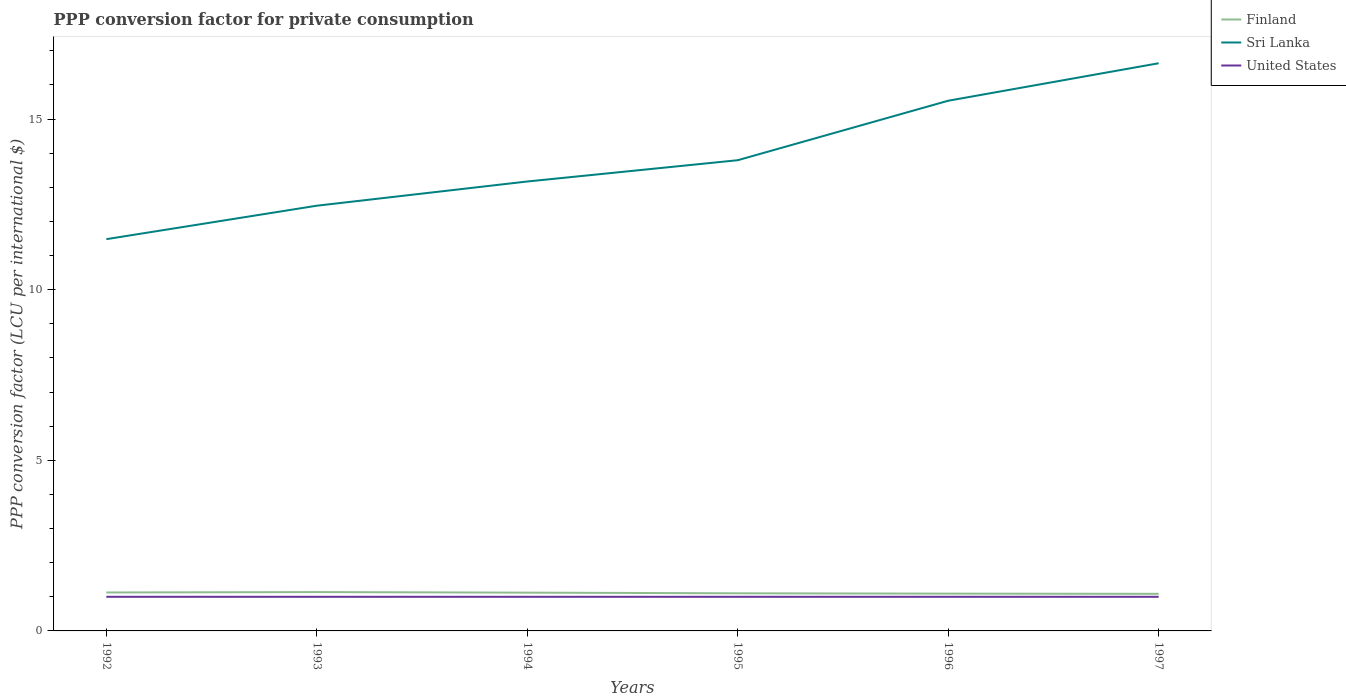How many different coloured lines are there?
Give a very brief answer. 3. Across all years, what is the maximum PPP conversion factor for private consumption in Finland?
Your response must be concise. 1.09. What is the total PPP conversion factor for private consumption in Finland in the graph?
Offer a terse response. 0.04. What is the difference between the highest and the second highest PPP conversion factor for private consumption in Sri Lanka?
Your answer should be very brief. 5.16. What is the difference between the highest and the lowest PPP conversion factor for private consumption in United States?
Keep it short and to the point. 0. What is the difference between two consecutive major ticks on the Y-axis?
Offer a very short reply. 5. Does the graph contain any zero values?
Make the answer very short. No. How are the legend labels stacked?
Ensure brevity in your answer.  Vertical. What is the title of the graph?
Ensure brevity in your answer.  PPP conversion factor for private consumption. What is the label or title of the Y-axis?
Ensure brevity in your answer.  PPP conversion factor (LCU per international $). What is the PPP conversion factor (LCU per international $) of Finland in 1992?
Your answer should be compact. 1.13. What is the PPP conversion factor (LCU per international $) in Sri Lanka in 1992?
Offer a terse response. 11.48. What is the PPP conversion factor (LCU per international $) of United States in 1992?
Provide a succinct answer. 1. What is the PPP conversion factor (LCU per international $) of Finland in 1993?
Provide a succinct answer. 1.14. What is the PPP conversion factor (LCU per international $) of Sri Lanka in 1993?
Ensure brevity in your answer.  12.46. What is the PPP conversion factor (LCU per international $) of Finland in 1994?
Your response must be concise. 1.12. What is the PPP conversion factor (LCU per international $) in Sri Lanka in 1994?
Your answer should be compact. 13.17. What is the PPP conversion factor (LCU per international $) in Finland in 1995?
Offer a very short reply. 1.1. What is the PPP conversion factor (LCU per international $) of Sri Lanka in 1995?
Keep it short and to the point. 13.79. What is the PPP conversion factor (LCU per international $) in United States in 1995?
Make the answer very short. 1. What is the PPP conversion factor (LCU per international $) in Finland in 1996?
Make the answer very short. 1.09. What is the PPP conversion factor (LCU per international $) of Sri Lanka in 1996?
Provide a short and direct response. 15.54. What is the PPP conversion factor (LCU per international $) in Finland in 1997?
Your answer should be compact. 1.09. What is the PPP conversion factor (LCU per international $) in Sri Lanka in 1997?
Offer a terse response. 16.64. Across all years, what is the maximum PPP conversion factor (LCU per international $) in Finland?
Ensure brevity in your answer.  1.14. Across all years, what is the maximum PPP conversion factor (LCU per international $) of Sri Lanka?
Your answer should be very brief. 16.64. Across all years, what is the maximum PPP conversion factor (LCU per international $) in United States?
Make the answer very short. 1. Across all years, what is the minimum PPP conversion factor (LCU per international $) in Finland?
Offer a terse response. 1.09. Across all years, what is the minimum PPP conversion factor (LCU per international $) of Sri Lanka?
Ensure brevity in your answer.  11.48. What is the total PPP conversion factor (LCU per international $) of Finland in the graph?
Give a very brief answer. 6.67. What is the total PPP conversion factor (LCU per international $) of Sri Lanka in the graph?
Offer a very short reply. 83.08. What is the difference between the PPP conversion factor (LCU per international $) of Finland in 1992 and that in 1993?
Make the answer very short. -0.01. What is the difference between the PPP conversion factor (LCU per international $) in Sri Lanka in 1992 and that in 1993?
Ensure brevity in your answer.  -0.98. What is the difference between the PPP conversion factor (LCU per international $) in Finland in 1992 and that in 1994?
Ensure brevity in your answer.  0. What is the difference between the PPP conversion factor (LCU per international $) in Sri Lanka in 1992 and that in 1994?
Your answer should be compact. -1.69. What is the difference between the PPP conversion factor (LCU per international $) of Finland in 1992 and that in 1995?
Offer a very short reply. 0.02. What is the difference between the PPP conversion factor (LCU per international $) of Sri Lanka in 1992 and that in 1995?
Make the answer very short. -2.31. What is the difference between the PPP conversion factor (LCU per international $) in United States in 1992 and that in 1995?
Your response must be concise. 0. What is the difference between the PPP conversion factor (LCU per international $) of Finland in 1992 and that in 1996?
Provide a short and direct response. 0.03. What is the difference between the PPP conversion factor (LCU per international $) in Sri Lanka in 1992 and that in 1996?
Provide a succinct answer. -4.06. What is the difference between the PPP conversion factor (LCU per international $) of United States in 1992 and that in 1996?
Keep it short and to the point. 0. What is the difference between the PPP conversion factor (LCU per international $) of Finland in 1992 and that in 1997?
Give a very brief answer. 0.04. What is the difference between the PPP conversion factor (LCU per international $) in Sri Lanka in 1992 and that in 1997?
Offer a very short reply. -5.16. What is the difference between the PPP conversion factor (LCU per international $) of Finland in 1993 and that in 1994?
Provide a succinct answer. 0.02. What is the difference between the PPP conversion factor (LCU per international $) in Sri Lanka in 1993 and that in 1994?
Your answer should be very brief. -0.71. What is the difference between the PPP conversion factor (LCU per international $) of United States in 1993 and that in 1994?
Provide a succinct answer. 0. What is the difference between the PPP conversion factor (LCU per international $) of Finland in 1993 and that in 1995?
Offer a terse response. 0.04. What is the difference between the PPP conversion factor (LCU per international $) in Sri Lanka in 1993 and that in 1995?
Make the answer very short. -1.33. What is the difference between the PPP conversion factor (LCU per international $) of Finland in 1993 and that in 1996?
Your response must be concise. 0.05. What is the difference between the PPP conversion factor (LCU per international $) of Sri Lanka in 1993 and that in 1996?
Ensure brevity in your answer.  -3.08. What is the difference between the PPP conversion factor (LCU per international $) in United States in 1993 and that in 1996?
Make the answer very short. 0. What is the difference between the PPP conversion factor (LCU per international $) of Finland in 1993 and that in 1997?
Ensure brevity in your answer.  0.05. What is the difference between the PPP conversion factor (LCU per international $) in Sri Lanka in 1993 and that in 1997?
Offer a very short reply. -4.17. What is the difference between the PPP conversion factor (LCU per international $) of United States in 1993 and that in 1997?
Your response must be concise. 0. What is the difference between the PPP conversion factor (LCU per international $) of Finland in 1994 and that in 1995?
Your response must be concise. 0.02. What is the difference between the PPP conversion factor (LCU per international $) in Sri Lanka in 1994 and that in 1995?
Offer a terse response. -0.62. What is the difference between the PPP conversion factor (LCU per international $) of United States in 1994 and that in 1995?
Ensure brevity in your answer.  0. What is the difference between the PPP conversion factor (LCU per international $) in Finland in 1994 and that in 1996?
Your response must be concise. 0.03. What is the difference between the PPP conversion factor (LCU per international $) in Sri Lanka in 1994 and that in 1996?
Make the answer very short. -2.37. What is the difference between the PPP conversion factor (LCU per international $) of Finland in 1994 and that in 1997?
Make the answer very short. 0.03. What is the difference between the PPP conversion factor (LCU per international $) of Sri Lanka in 1994 and that in 1997?
Give a very brief answer. -3.47. What is the difference between the PPP conversion factor (LCU per international $) of Finland in 1995 and that in 1996?
Your response must be concise. 0.01. What is the difference between the PPP conversion factor (LCU per international $) in Sri Lanka in 1995 and that in 1996?
Your answer should be very brief. -1.74. What is the difference between the PPP conversion factor (LCU per international $) in Finland in 1995 and that in 1997?
Ensure brevity in your answer.  0.02. What is the difference between the PPP conversion factor (LCU per international $) in Sri Lanka in 1995 and that in 1997?
Ensure brevity in your answer.  -2.84. What is the difference between the PPP conversion factor (LCU per international $) in Finland in 1996 and that in 1997?
Give a very brief answer. 0.01. What is the difference between the PPP conversion factor (LCU per international $) of Sri Lanka in 1996 and that in 1997?
Keep it short and to the point. -1.1. What is the difference between the PPP conversion factor (LCU per international $) in United States in 1996 and that in 1997?
Ensure brevity in your answer.  0. What is the difference between the PPP conversion factor (LCU per international $) of Finland in 1992 and the PPP conversion factor (LCU per international $) of Sri Lanka in 1993?
Provide a succinct answer. -11.34. What is the difference between the PPP conversion factor (LCU per international $) of Finland in 1992 and the PPP conversion factor (LCU per international $) of United States in 1993?
Provide a short and direct response. 0.13. What is the difference between the PPP conversion factor (LCU per international $) in Sri Lanka in 1992 and the PPP conversion factor (LCU per international $) in United States in 1993?
Your response must be concise. 10.48. What is the difference between the PPP conversion factor (LCU per international $) of Finland in 1992 and the PPP conversion factor (LCU per international $) of Sri Lanka in 1994?
Offer a very short reply. -12.04. What is the difference between the PPP conversion factor (LCU per international $) in Finland in 1992 and the PPP conversion factor (LCU per international $) in United States in 1994?
Make the answer very short. 0.13. What is the difference between the PPP conversion factor (LCU per international $) of Sri Lanka in 1992 and the PPP conversion factor (LCU per international $) of United States in 1994?
Your answer should be very brief. 10.48. What is the difference between the PPP conversion factor (LCU per international $) of Finland in 1992 and the PPP conversion factor (LCU per international $) of Sri Lanka in 1995?
Your response must be concise. -12.67. What is the difference between the PPP conversion factor (LCU per international $) of Finland in 1992 and the PPP conversion factor (LCU per international $) of United States in 1995?
Your answer should be compact. 0.13. What is the difference between the PPP conversion factor (LCU per international $) in Sri Lanka in 1992 and the PPP conversion factor (LCU per international $) in United States in 1995?
Offer a terse response. 10.48. What is the difference between the PPP conversion factor (LCU per international $) of Finland in 1992 and the PPP conversion factor (LCU per international $) of Sri Lanka in 1996?
Your answer should be very brief. -14.41. What is the difference between the PPP conversion factor (LCU per international $) of Finland in 1992 and the PPP conversion factor (LCU per international $) of United States in 1996?
Ensure brevity in your answer.  0.13. What is the difference between the PPP conversion factor (LCU per international $) in Sri Lanka in 1992 and the PPP conversion factor (LCU per international $) in United States in 1996?
Your answer should be compact. 10.48. What is the difference between the PPP conversion factor (LCU per international $) in Finland in 1992 and the PPP conversion factor (LCU per international $) in Sri Lanka in 1997?
Provide a short and direct response. -15.51. What is the difference between the PPP conversion factor (LCU per international $) of Finland in 1992 and the PPP conversion factor (LCU per international $) of United States in 1997?
Provide a succinct answer. 0.13. What is the difference between the PPP conversion factor (LCU per international $) in Sri Lanka in 1992 and the PPP conversion factor (LCU per international $) in United States in 1997?
Your answer should be compact. 10.48. What is the difference between the PPP conversion factor (LCU per international $) in Finland in 1993 and the PPP conversion factor (LCU per international $) in Sri Lanka in 1994?
Ensure brevity in your answer.  -12.03. What is the difference between the PPP conversion factor (LCU per international $) of Finland in 1993 and the PPP conversion factor (LCU per international $) of United States in 1994?
Give a very brief answer. 0.14. What is the difference between the PPP conversion factor (LCU per international $) in Sri Lanka in 1993 and the PPP conversion factor (LCU per international $) in United States in 1994?
Make the answer very short. 11.46. What is the difference between the PPP conversion factor (LCU per international $) of Finland in 1993 and the PPP conversion factor (LCU per international $) of Sri Lanka in 1995?
Keep it short and to the point. -12.66. What is the difference between the PPP conversion factor (LCU per international $) in Finland in 1993 and the PPP conversion factor (LCU per international $) in United States in 1995?
Offer a very short reply. 0.14. What is the difference between the PPP conversion factor (LCU per international $) of Sri Lanka in 1993 and the PPP conversion factor (LCU per international $) of United States in 1995?
Provide a succinct answer. 11.46. What is the difference between the PPP conversion factor (LCU per international $) in Finland in 1993 and the PPP conversion factor (LCU per international $) in Sri Lanka in 1996?
Provide a short and direct response. -14.4. What is the difference between the PPP conversion factor (LCU per international $) in Finland in 1993 and the PPP conversion factor (LCU per international $) in United States in 1996?
Ensure brevity in your answer.  0.14. What is the difference between the PPP conversion factor (LCU per international $) in Sri Lanka in 1993 and the PPP conversion factor (LCU per international $) in United States in 1996?
Offer a terse response. 11.46. What is the difference between the PPP conversion factor (LCU per international $) in Finland in 1993 and the PPP conversion factor (LCU per international $) in Sri Lanka in 1997?
Your response must be concise. -15.5. What is the difference between the PPP conversion factor (LCU per international $) of Finland in 1993 and the PPP conversion factor (LCU per international $) of United States in 1997?
Your answer should be compact. 0.14. What is the difference between the PPP conversion factor (LCU per international $) in Sri Lanka in 1993 and the PPP conversion factor (LCU per international $) in United States in 1997?
Ensure brevity in your answer.  11.46. What is the difference between the PPP conversion factor (LCU per international $) of Finland in 1994 and the PPP conversion factor (LCU per international $) of Sri Lanka in 1995?
Provide a short and direct response. -12.67. What is the difference between the PPP conversion factor (LCU per international $) in Finland in 1994 and the PPP conversion factor (LCU per international $) in United States in 1995?
Your answer should be very brief. 0.12. What is the difference between the PPP conversion factor (LCU per international $) in Sri Lanka in 1994 and the PPP conversion factor (LCU per international $) in United States in 1995?
Provide a succinct answer. 12.17. What is the difference between the PPP conversion factor (LCU per international $) in Finland in 1994 and the PPP conversion factor (LCU per international $) in Sri Lanka in 1996?
Your answer should be compact. -14.42. What is the difference between the PPP conversion factor (LCU per international $) of Finland in 1994 and the PPP conversion factor (LCU per international $) of United States in 1996?
Offer a terse response. 0.12. What is the difference between the PPP conversion factor (LCU per international $) of Sri Lanka in 1994 and the PPP conversion factor (LCU per international $) of United States in 1996?
Provide a succinct answer. 12.17. What is the difference between the PPP conversion factor (LCU per international $) of Finland in 1994 and the PPP conversion factor (LCU per international $) of Sri Lanka in 1997?
Keep it short and to the point. -15.51. What is the difference between the PPP conversion factor (LCU per international $) of Finland in 1994 and the PPP conversion factor (LCU per international $) of United States in 1997?
Provide a succinct answer. 0.12. What is the difference between the PPP conversion factor (LCU per international $) in Sri Lanka in 1994 and the PPP conversion factor (LCU per international $) in United States in 1997?
Ensure brevity in your answer.  12.17. What is the difference between the PPP conversion factor (LCU per international $) of Finland in 1995 and the PPP conversion factor (LCU per international $) of Sri Lanka in 1996?
Provide a short and direct response. -14.44. What is the difference between the PPP conversion factor (LCU per international $) in Finland in 1995 and the PPP conversion factor (LCU per international $) in United States in 1996?
Provide a succinct answer. 0.1. What is the difference between the PPP conversion factor (LCU per international $) of Sri Lanka in 1995 and the PPP conversion factor (LCU per international $) of United States in 1996?
Offer a terse response. 12.79. What is the difference between the PPP conversion factor (LCU per international $) in Finland in 1995 and the PPP conversion factor (LCU per international $) in Sri Lanka in 1997?
Your answer should be compact. -15.53. What is the difference between the PPP conversion factor (LCU per international $) of Finland in 1995 and the PPP conversion factor (LCU per international $) of United States in 1997?
Your answer should be very brief. 0.1. What is the difference between the PPP conversion factor (LCU per international $) in Sri Lanka in 1995 and the PPP conversion factor (LCU per international $) in United States in 1997?
Your answer should be very brief. 12.79. What is the difference between the PPP conversion factor (LCU per international $) of Finland in 1996 and the PPP conversion factor (LCU per international $) of Sri Lanka in 1997?
Provide a short and direct response. -15.54. What is the difference between the PPP conversion factor (LCU per international $) of Finland in 1996 and the PPP conversion factor (LCU per international $) of United States in 1997?
Offer a terse response. 0.09. What is the difference between the PPP conversion factor (LCU per international $) in Sri Lanka in 1996 and the PPP conversion factor (LCU per international $) in United States in 1997?
Keep it short and to the point. 14.54. What is the average PPP conversion factor (LCU per international $) of Finland per year?
Provide a short and direct response. 1.11. What is the average PPP conversion factor (LCU per international $) of Sri Lanka per year?
Keep it short and to the point. 13.85. In the year 1992, what is the difference between the PPP conversion factor (LCU per international $) of Finland and PPP conversion factor (LCU per international $) of Sri Lanka?
Give a very brief answer. -10.35. In the year 1992, what is the difference between the PPP conversion factor (LCU per international $) in Finland and PPP conversion factor (LCU per international $) in United States?
Your answer should be compact. 0.13. In the year 1992, what is the difference between the PPP conversion factor (LCU per international $) in Sri Lanka and PPP conversion factor (LCU per international $) in United States?
Offer a very short reply. 10.48. In the year 1993, what is the difference between the PPP conversion factor (LCU per international $) of Finland and PPP conversion factor (LCU per international $) of Sri Lanka?
Offer a terse response. -11.32. In the year 1993, what is the difference between the PPP conversion factor (LCU per international $) in Finland and PPP conversion factor (LCU per international $) in United States?
Your answer should be compact. 0.14. In the year 1993, what is the difference between the PPP conversion factor (LCU per international $) in Sri Lanka and PPP conversion factor (LCU per international $) in United States?
Provide a succinct answer. 11.46. In the year 1994, what is the difference between the PPP conversion factor (LCU per international $) in Finland and PPP conversion factor (LCU per international $) in Sri Lanka?
Offer a very short reply. -12.05. In the year 1994, what is the difference between the PPP conversion factor (LCU per international $) of Finland and PPP conversion factor (LCU per international $) of United States?
Provide a succinct answer. 0.12. In the year 1994, what is the difference between the PPP conversion factor (LCU per international $) of Sri Lanka and PPP conversion factor (LCU per international $) of United States?
Give a very brief answer. 12.17. In the year 1995, what is the difference between the PPP conversion factor (LCU per international $) in Finland and PPP conversion factor (LCU per international $) in Sri Lanka?
Offer a terse response. -12.69. In the year 1995, what is the difference between the PPP conversion factor (LCU per international $) of Finland and PPP conversion factor (LCU per international $) of United States?
Provide a short and direct response. 0.1. In the year 1995, what is the difference between the PPP conversion factor (LCU per international $) in Sri Lanka and PPP conversion factor (LCU per international $) in United States?
Provide a succinct answer. 12.79. In the year 1996, what is the difference between the PPP conversion factor (LCU per international $) in Finland and PPP conversion factor (LCU per international $) in Sri Lanka?
Offer a terse response. -14.45. In the year 1996, what is the difference between the PPP conversion factor (LCU per international $) in Finland and PPP conversion factor (LCU per international $) in United States?
Give a very brief answer. 0.09. In the year 1996, what is the difference between the PPP conversion factor (LCU per international $) of Sri Lanka and PPP conversion factor (LCU per international $) of United States?
Make the answer very short. 14.54. In the year 1997, what is the difference between the PPP conversion factor (LCU per international $) in Finland and PPP conversion factor (LCU per international $) in Sri Lanka?
Provide a short and direct response. -15.55. In the year 1997, what is the difference between the PPP conversion factor (LCU per international $) in Finland and PPP conversion factor (LCU per international $) in United States?
Ensure brevity in your answer.  0.09. In the year 1997, what is the difference between the PPP conversion factor (LCU per international $) in Sri Lanka and PPP conversion factor (LCU per international $) in United States?
Provide a short and direct response. 15.64. What is the ratio of the PPP conversion factor (LCU per international $) in Sri Lanka in 1992 to that in 1993?
Make the answer very short. 0.92. What is the ratio of the PPP conversion factor (LCU per international $) of United States in 1992 to that in 1993?
Your response must be concise. 1. What is the ratio of the PPP conversion factor (LCU per international $) of Sri Lanka in 1992 to that in 1994?
Offer a very short reply. 0.87. What is the ratio of the PPP conversion factor (LCU per international $) in United States in 1992 to that in 1994?
Give a very brief answer. 1. What is the ratio of the PPP conversion factor (LCU per international $) of Finland in 1992 to that in 1995?
Offer a very short reply. 1.02. What is the ratio of the PPP conversion factor (LCU per international $) in Sri Lanka in 1992 to that in 1995?
Make the answer very short. 0.83. What is the ratio of the PPP conversion factor (LCU per international $) in Finland in 1992 to that in 1996?
Give a very brief answer. 1.03. What is the ratio of the PPP conversion factor (LCU per international $) in Sri Lanka in 1992 to that in 1996?
Your response must be concise. 0.74. What is the ratio of the PPP conversion factor (LCU per international $) of United States in 1992 to that in 1996?
Make the answer very short. 1. What is the ratio of the PPP conversion factor (LCU per international $) in Finland in 1992 to that in 1997?
Provide a short and direct response. 1.04. What is the ratio of the PPP conversion factor (LCU per international $) in Sri Lanka in 1992 to that in 1997?
Your answer should be compact. 0.69. What is the ratio of the PPP conversion factor (LCU per international $) in Finland in 1993 to that in 1994?
Make the answer very short. 1.01. What is the ratio of the PPP conversion factor (LCU per international $) of Sri Lanka in 1993 to that in 1994?
Ensure brevity in your answer.  0.95. What is the ratio of the PPP conversion factor (LCU per international $) in Finland in 1993 to that in 1995?
Make the answer very short. 1.03. What is the ratio of the PPP conversion factor (LCU per international $) in Sri Lanka in 1993 to that in 1995?
Keep it short and to the point. 0.9. What is the ratio of the PPP conversion factor (LCU per international $) of Finland in 1993 to that in 1996?
Offer a very short reply. 1.04. What is the ratio of the PPP conversion factor (LCU per international $) of Sri Lanka in 1993 to that in 1996?
Make the answer very short. 0.8. What is the ratio of the PPP conversion factor (LCU per international $) of United States in 1993 to that in 1996?
Your answer should be very brief. 1. What is the ratio of the PPP conversion factor (LCU per international $) of Finland in 1993 to that in 1997?
Your answer should be very brief. 1.05. What is the ratio of the PPP conversion factor (LCU per international $) in Sri Lanka in 1993 to that in 1997?
Keep it short and to the point. 0.75. What is the ratio of the PPP conversion factor (LCU per international $) of United States in 1993 to that in 1997?
Offer a terse response. 1. What is the ratio of the PPP conversion factor (LCU per international $) of Finland in 1994 to that in 1995?
Provide a succinct answer. 1.02. What is the ratio of the PPP conversion factor (LCU per international $) of Sri Lanka in 1994 to that in 1995?
Offer a terse response. 0.95. What is the ratio of the PPP conversion factor (LCU per international $) in Finland in 1994 to that in 1996?
Your answer should be compact. 1.03. What is the ratio of the PPP conversion factor (LCU per international $) in Sri Lanka in 1994 to that in 1996?
Offer a terse response. 0.85. What is the ratio of the PPP conversion factor (LCU per international $) in Finland in 1994 to that in 1997?
Give a very brief answer. 1.03. What is the ratio of the PPP conversion factor (LCU per international $) in Sri Lanka in 1994 to that in 1997?
Give a very brief answer. 0.79. What is the ratio of the PPP conversion factor (LCU per international $) of United States in 1994 to that in 1997?
Make the answer very short. 1. What is the ratio of the PPP conversion factor (LCU per international $) in Finland in 1995 to that in 1996?
Your answer should be very brief. 1.01. What is the ratio of the PPP conversion factor (LCU per international $) of Sri Lanka in 1995 to that in 1996?
Your answer should be compact. 0.89. What is the ratio of the PPP conversion factor (LCU per international $) of United States in 1995 to that in 1996?
Your response must be concise. 1. What is the ratio of the PPP conversion factor (LCU per international $) of Finland in 1995 to that in 1997?
Ensure brevity in your answer.  1.01. What is the ratio of the PPP conversion factor (LCU per international $) in Sri Lanka in 1995 to that in 1997?
Provide a succinct answer. 0.83. What is the ratio of the PPP conversion factor (LCU per international $) in Finland in 1996 to that in 1997?
Provide a succinct answer. 1.01. What is the ratio of the PPP conversion factor (LCU per international $) in Sri Lanka in 1996 to that in 1997?
Give a very brief answer. 0.93. What is the difference between the highest and the second highest PPP conversion factor (LCU per international $) of Finland?
Offer a terse response. 0.01. What is the difference between the highest and the second highest PPP conversion factor (LCU per international $) of Sri Lanka?
Offer a terse response. 1.1. What is the difference between the highest and the lowest PPP conversion factor (LCU per international $) in Finland?
Offer a very short reply. 0.05. What is the difference between the highest and the lowest PPP conversion factor (LCU per international $) of Sri Lanka?
Your answer should be very brief. 5.16. What is the difference between the highest and the lowest PPP conversion factor (LCU per international $) of United States?
Offer a very short reply. 0. 